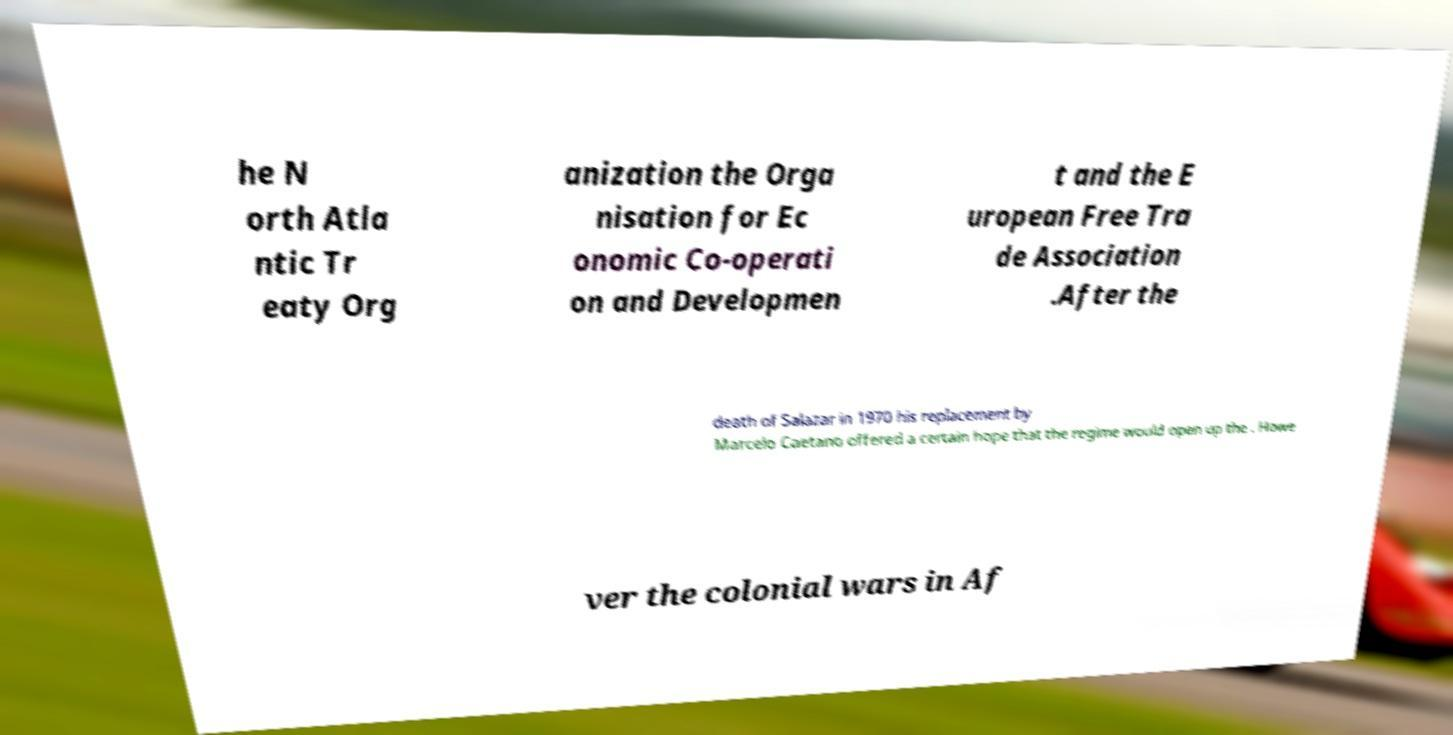Can you read and provide the text displayed in the image?This photo seems to have some interesting text. Can you extract and type it out for me? he N orth Atla ntic Tr eaty Org anization the Orga nisation for Ec onomic Co-operati on and Developmen t and the E uropean Free Tra de Association .After the death of Salazar in 1970 his replacement by Marcelo Caetano offered a certain hope that the regime would open up the . Howe ver the colonial wars in Af 